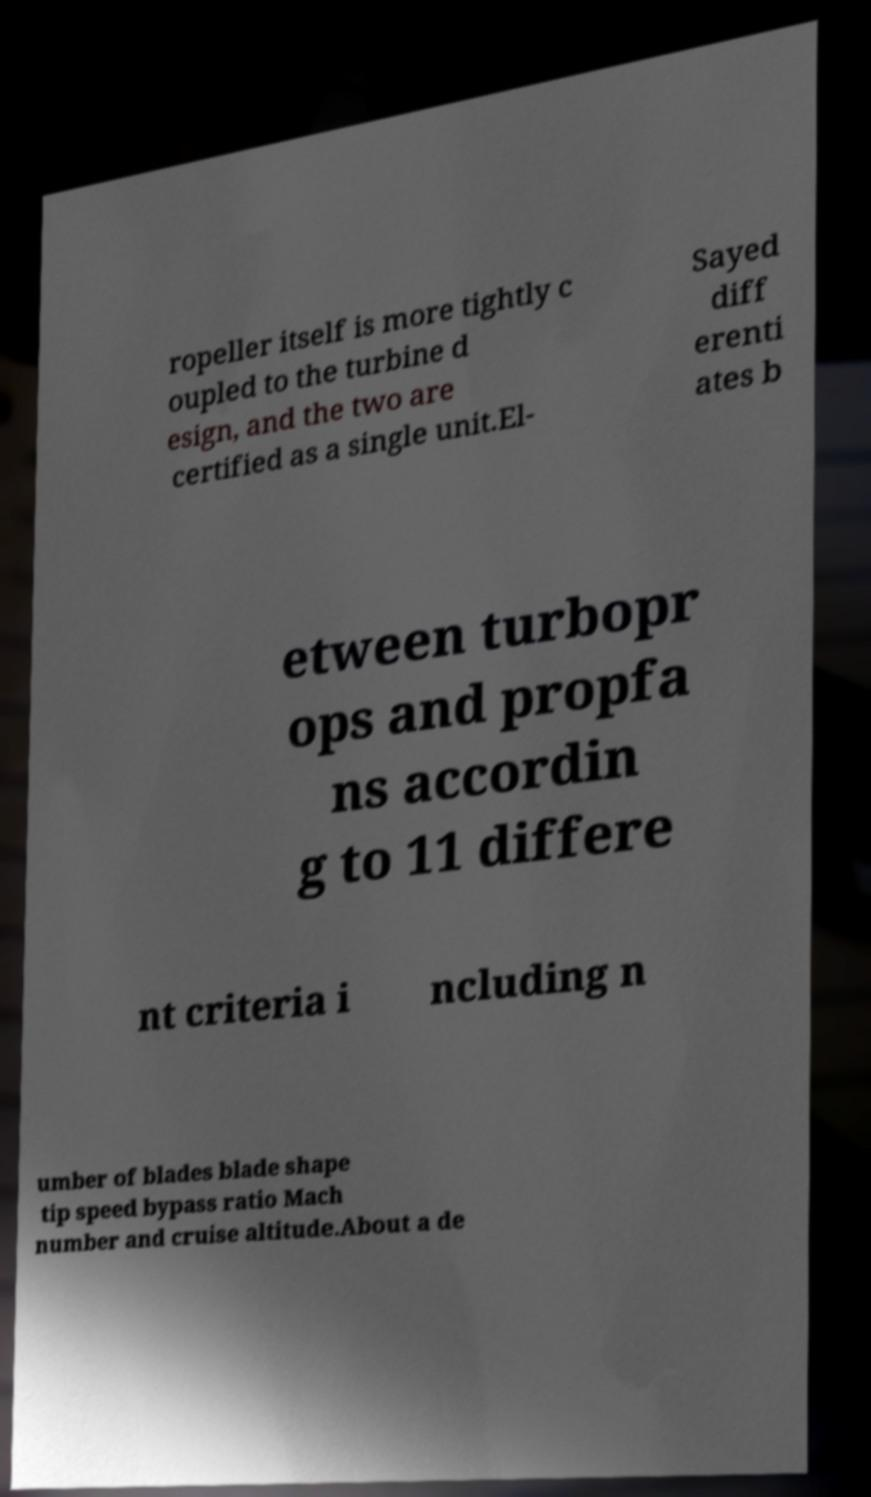Could you extract and type out the text from this image? ropeller itself is more tightly c oupled to the turbine d esign, and the two are certified as a single unit.El- Sayed diff erenti ates b etween turbopr ops and propfa ns accordin g to 11 differe nt criteria i ncluding n umber of blades blade shape tip speed bypass ratio Mach number and cruise altitude.About a de 